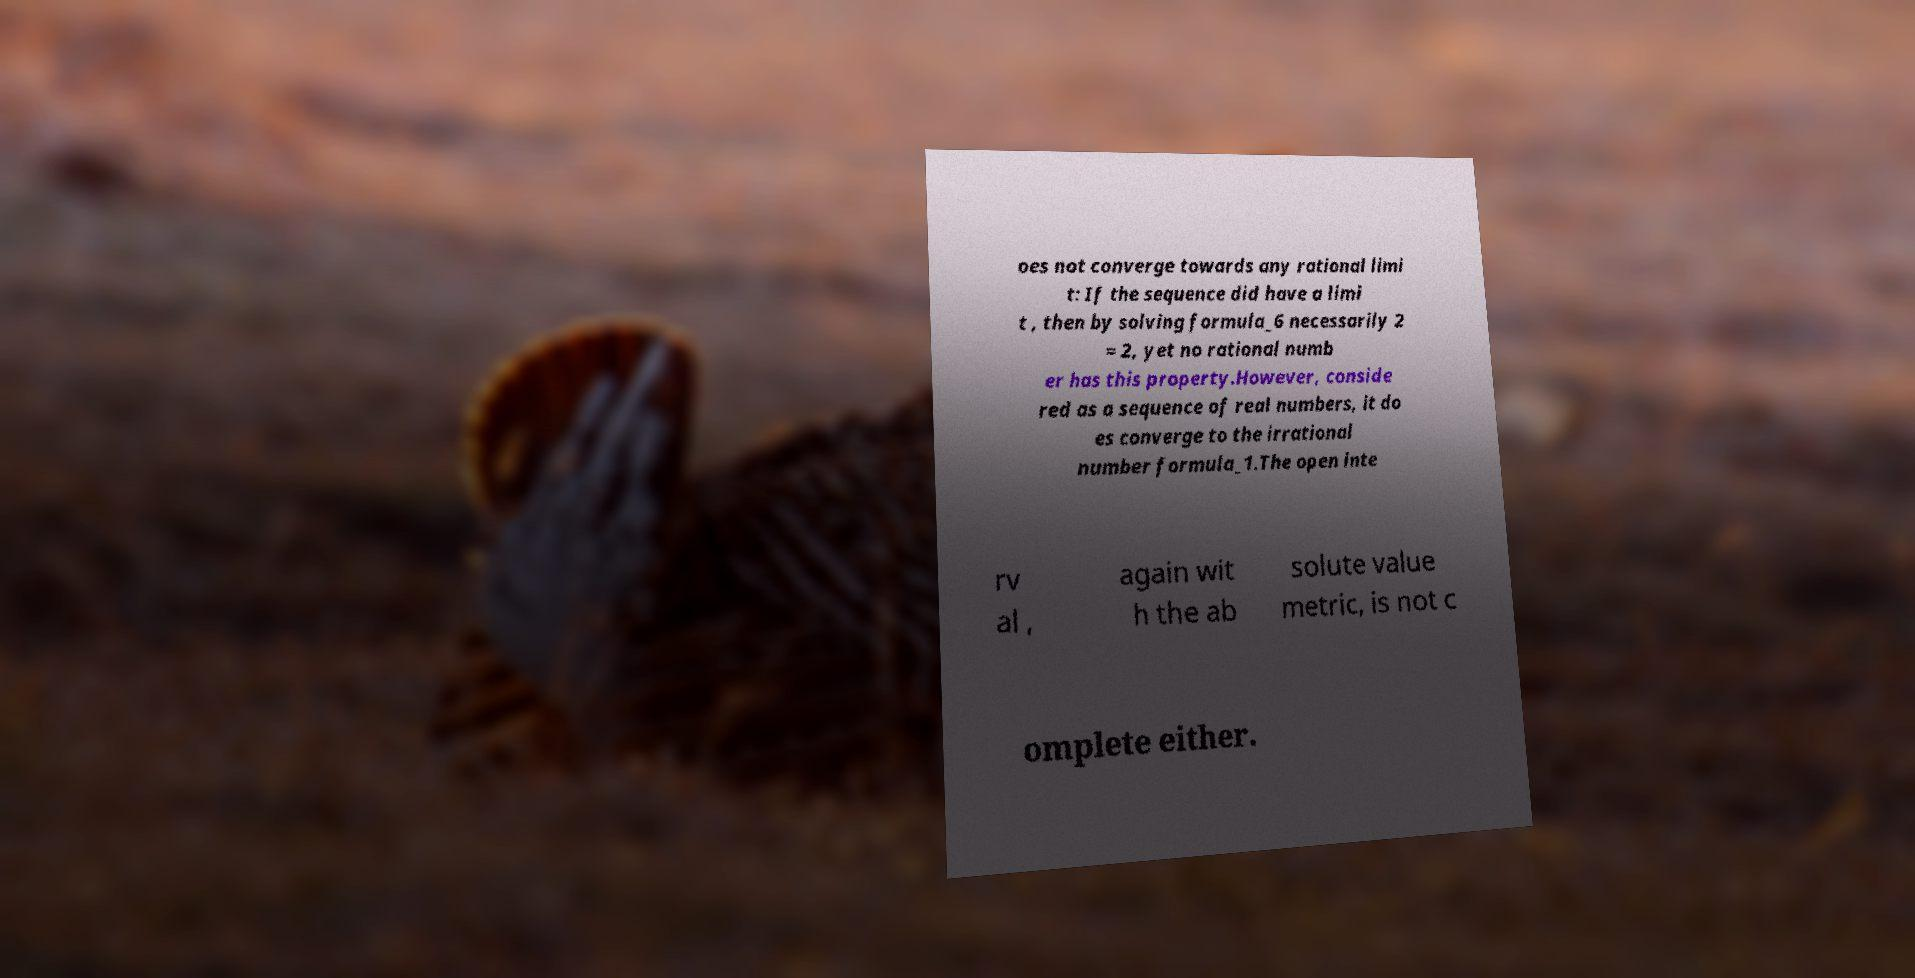Could you extract and type out the text from this image? oes not converge towards any rational limi t: If the sequence did have a limi t , then by solving formula_6 necessarily 2 = 2, yet no rational numb er has this property.However, conside red as a sequence of real numbers, it do es converge to the irrational number formula_1.The open inte rv al , again wit h the ab solute value metric, is not c omplete either. 